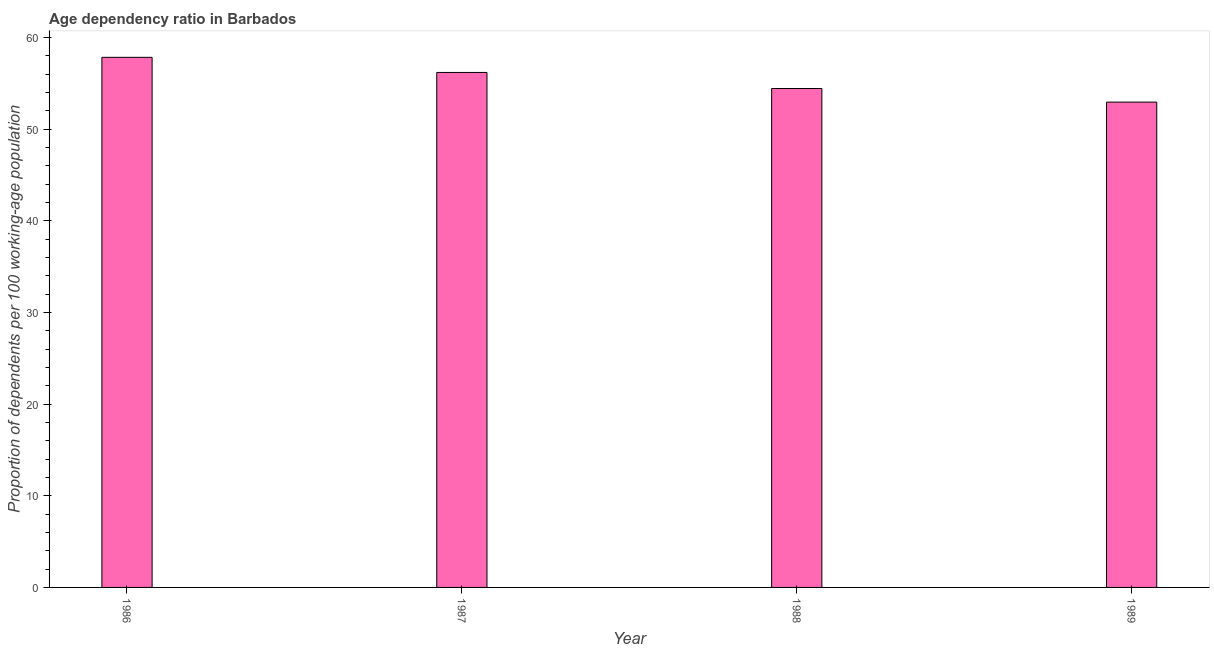Does the graph contain any zero values?
Make the answer very short. No. Does the graph contain grids?
Ensure brevity in your answer.  No. What is the title of the graph?
Your answer should be very brief. Age dependency ratio in Barbados. What is the label or title of the X-axis?
Provide a succinct answer. Year. What is the label or title of the Y-axis?
Your response must be concise. Proportion of dependents per 100 working-age population. What is the age dependency ratio in 1989?
Make the answer very short. 52.97. Across all years, what is the maximum age dependency ratio?
Your answer should be compact. 57.85. Across all years, what is the minimum age dependency ratio?
Keep it short and to the point. 52.97. In which year was the age dependency ratio minimum?
Provide a short and direct response. 1989. What is the sum of the age dependency ratio?
Your answer should be compact. 221.48. What is the difference between the age dependency ratio in 1987 and 1989?
Your answer should be very brief. 3.24. What is the average age dependency ratio per year?
Give a very brief answer. 55.37. What is the median age dependency ratio?
Give a very brief answer. 55.33. In how many years, is the age dependency ratio greater than 46 ?
Your answer should be very brief. 4. What is the ratio of the age dependency ratio in 1988 to that in 1989?
Provide a short and direct response. 1.03. Is the age dependency ratio in 1986 less than that in 1988?
Provide a short and direct response. No. Is the difference between the age dependency ratio in 1987 and 1988 greater than the difference between any two years?
Provide a succinct answer. No. What is the difference between the highest and the second highest age dependency ratio?
Your answer should be very brief. 1.65. Is the sum of the age dependency ratio in 1986 and 1989 greater than the maximum age dependency ratio across all years?
Provide a succinct answer. Yes. What is the difference between the highest and the lowest age dependency ratio?
Offer a terse response. 4.89. Are all the bars in the graph horizontal?
Your answer should be very brief. No. How many years are there in the graph?
Your answer should be compact. 4. What is the Proportion of dependents per 100 working-age population in 1986?
Provide a succinct answer. 57.85. What is the Proportion of dependents per 100 working-age population in 1987?
Your answer should be compact. 56.2. What is the Proportion of dependents per 100 working-age population in 1988?
Give a very brief answer. 54.45. What is the Proportion of dependents per 100 working-age population of 1989?
Your response must be concise. 52.97. What is the difference between the Proportion of dependents per 100 working-age population in 1986 and 1987?
Offer a terse response. 1.65. What is the difference between the Proportion of dependents per 100 working-age population in 1986 and 1988?
Your response must be concise. 3.4. What is the difference between the Proportion of dependents per 100 working-age population in 1986 and 1989?
Make the answer very short. 4.89. What is the difference between the Proportion of dependents per 100 working-age population in 1987 and 1988?
Provide a short and direct response. 1.75. What is the difference between the Proportion of dependents per 100 working-age population in 1987 and 1989?
Give a very brief answer. 3.24. What is the difference between the Proportion of dependents per 100 working-age population in 1988 and 1989?
Your answer should be compact. 1.49. What is the ratio of the Proportion of dependents per 100 working-age population in 1986 to that in 1988?
Make the answer very short. 1.06. What is the ratio of the Proportion of dependents per 100 working-age population in 1986 to that in 1989?
Your response must be concise. 1.09. What is the ratio of the Proportion of dependents per 100 working-age population in 1987 to that in 1988?
Provide a succinct answer. 1.03. What is the ratio of the Proportion of dependents per 100 working-age population in 1987 to that in 1989?
Keep it short and to the point. 1.06. What is the ratio of the Proportion of dependents per 100 working-age population in 1988 to that in 1989?
Offer a very short reply. 1.03. 